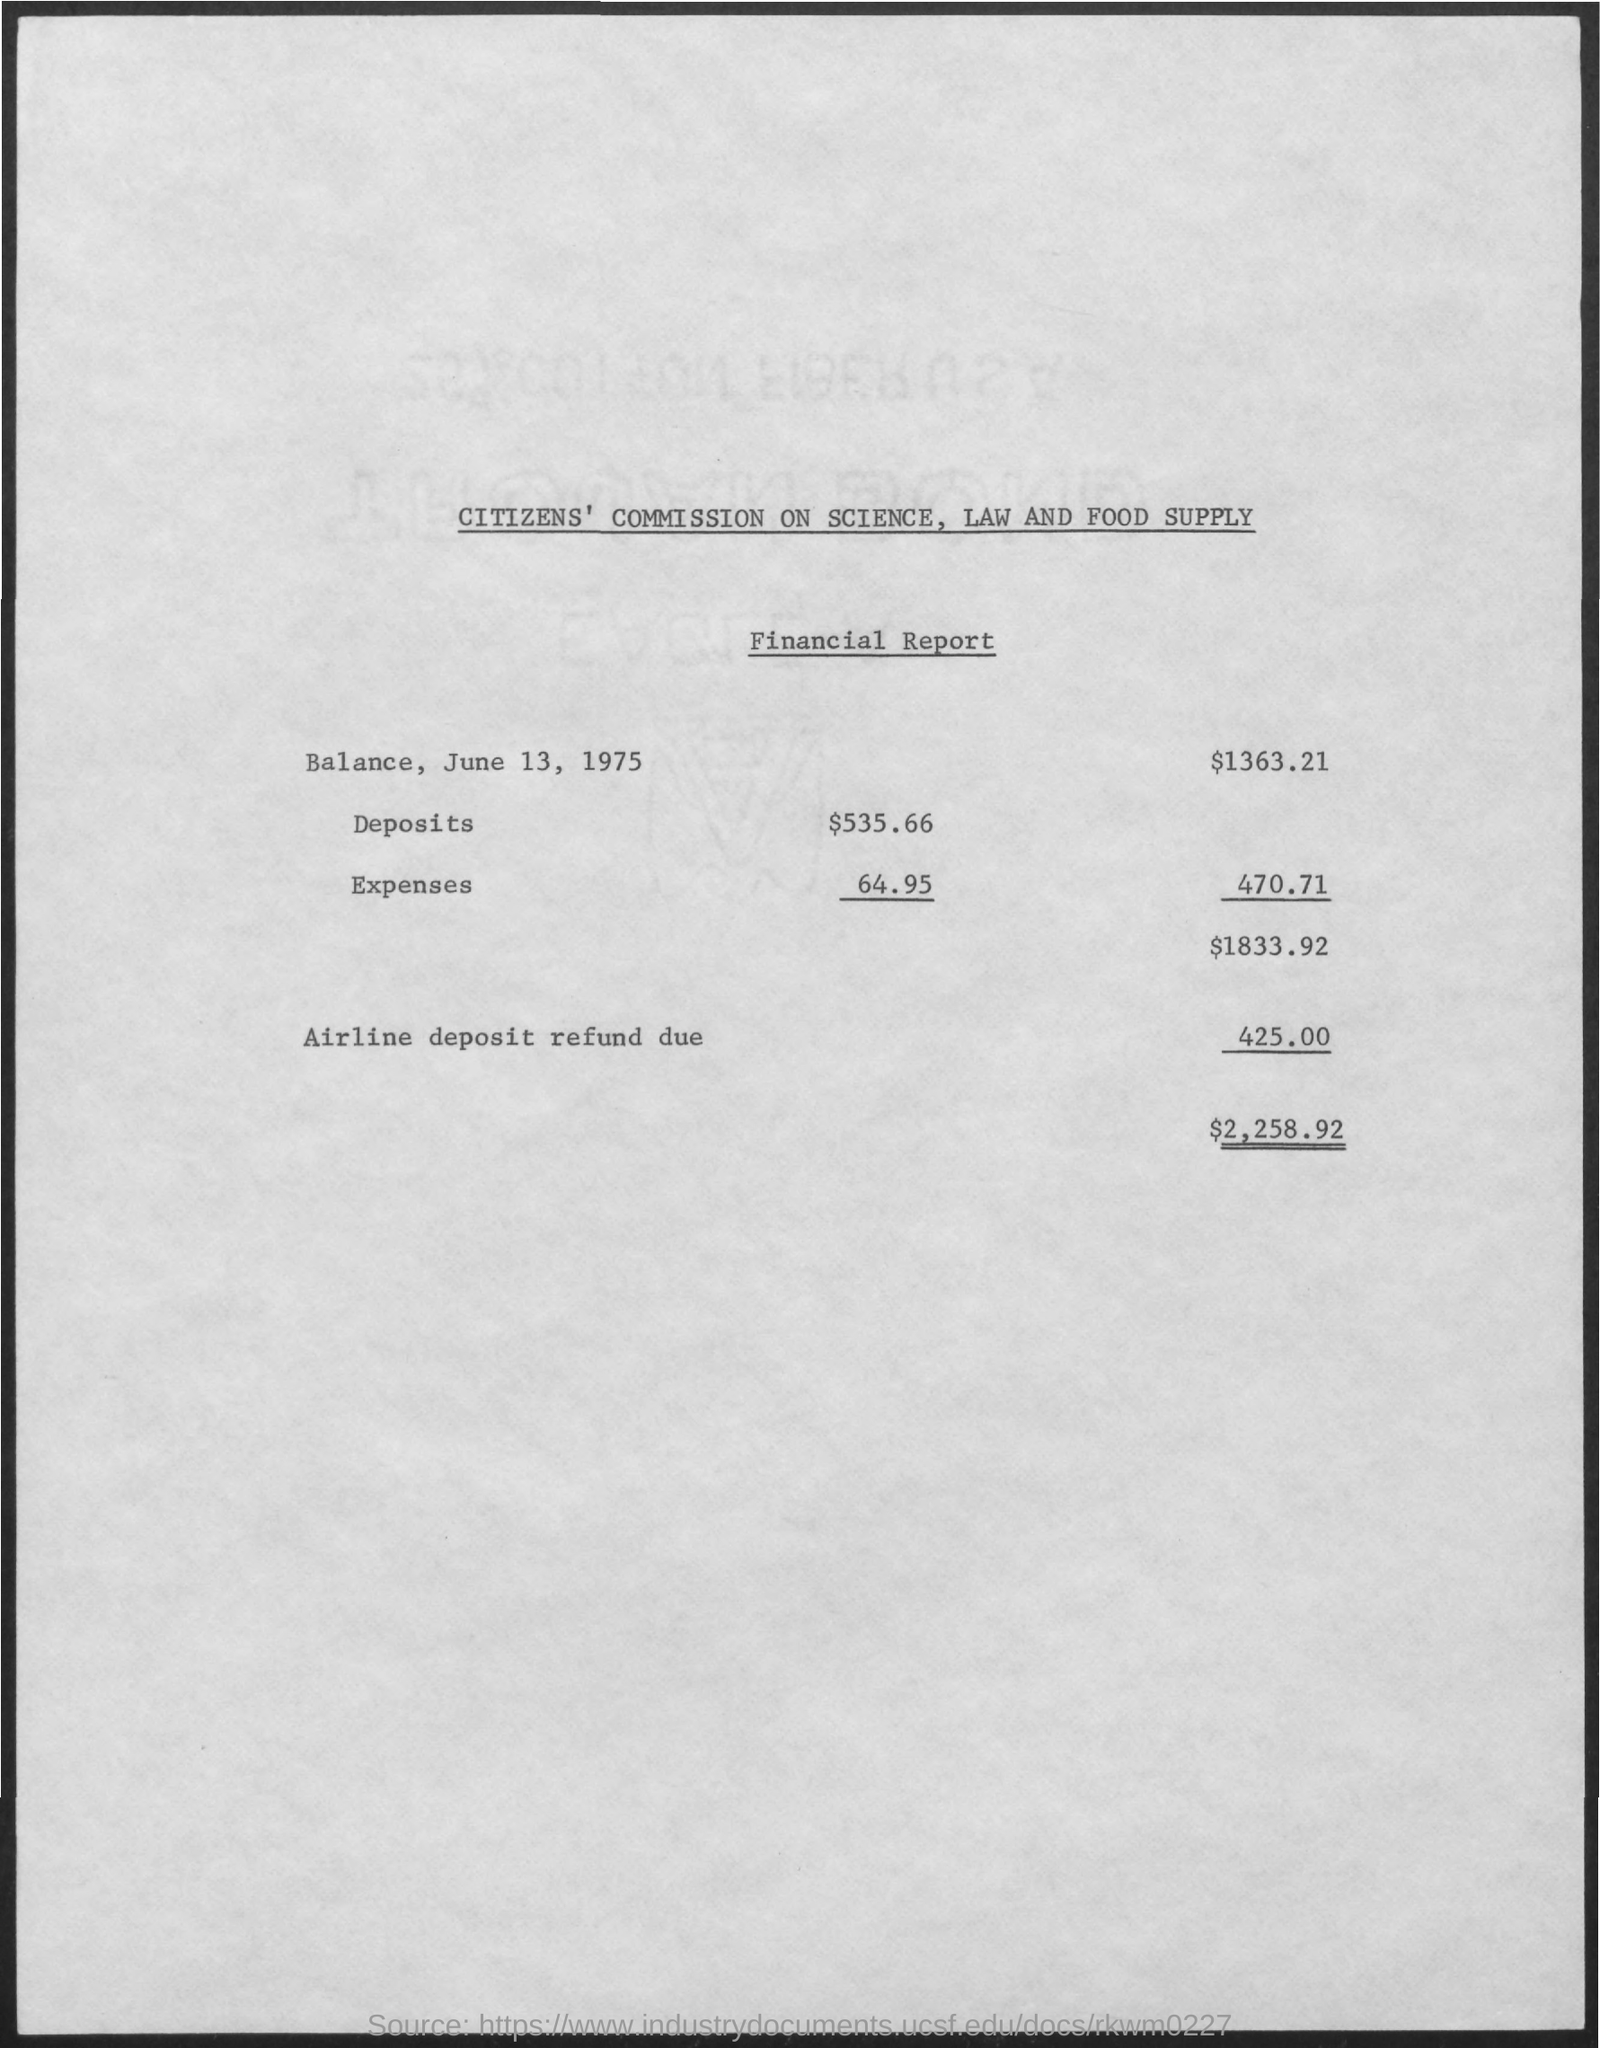What is the value of 'Deposits' ?
Provide a short and direct response. $535.66. What is the value of 'Balance, June 13, 1975' ?
Offer a terse response. $1363.21. 